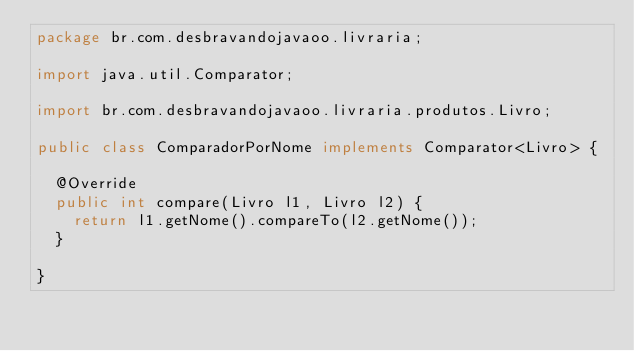<code> <loc_0><loc_0><loc_500><loc_500><_Java_>package br.com.desbravandojavaoo.livraria;

import java.util.Comparator;

import br.com.desbravandojavaoo.livraria.produtos.Livro;

public class ComparadorPorNome implements Comparator<Livro> {

	@Override
	public int compare(Livro l1, Livro l2) {
		return l1.getNome().compareTo(l2.getNome());
	}

}
</code> 